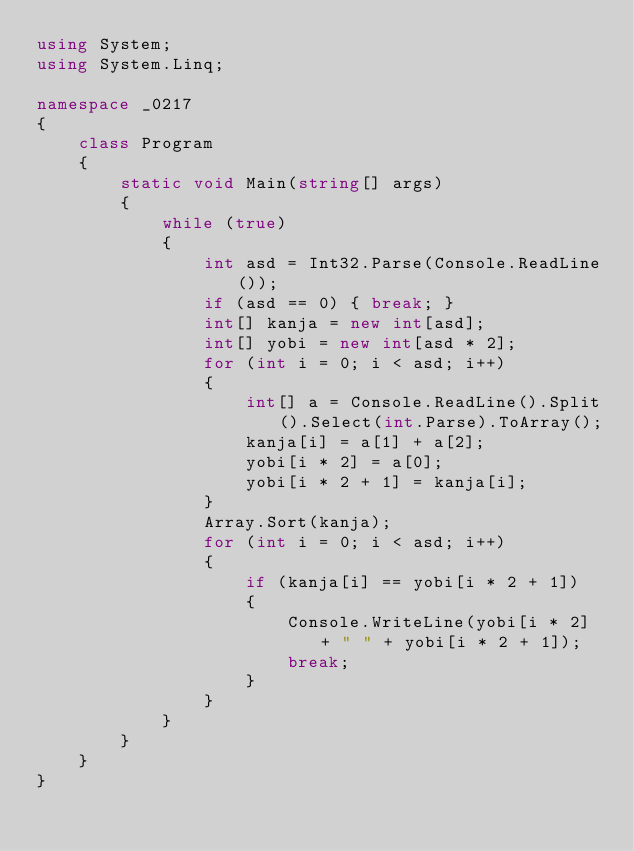<code> <loc_0><loc_0><loc_500><loc_500><_C#_>using System;
using System.Linq;

namespace _0217
{
    class Program
    {
        static void Main(string[] args)
        {
            while (true)
            {
                int asd = Int32.Parse(Console.ReadLine());
                if (asd == 0) { break; }
                int[] kanja = new int[asd];
                int[] yobi = new int[asd * 2];
                for (int i = 0; i < asd; i++)
                {
                    int[] a = Console.ReadLine().Split().Select(int.Parse).ToArray();
                    kanja[i] = a[1] + a[2];
                    yobi[i * 2] = a[0];
                    yobi[i * 2 + 1] = kanja[i];
                }
                Array.Sort(kanja);
                for (int i = 0; i < asd; i++)
                {
                    if (kanja[i] == yobi[i * 2 + 1])
                    {
                        Console.WriteLine(yobi[i * 2] + " " + yobi[i * 2 + 1]);
                        break;
                    }
                }
            }
        }
    }
}</code> 